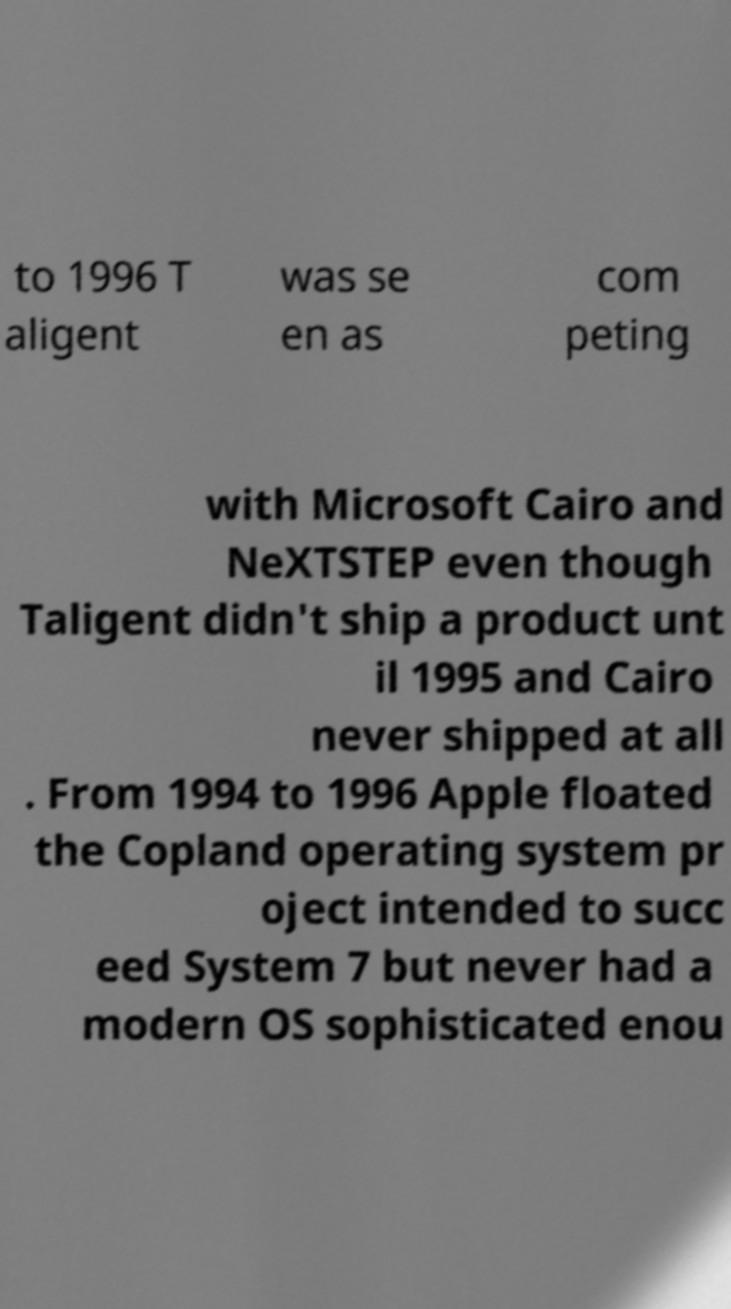There's text embedded in this image that I need extracted. Can you transcribe it verbatim? to 1996 T aligent was se en as com peting with Microsoft Cairo and NeXTSTEP even though Taligent didn't ship a product unt il 1995 and Cairo never shipped at all . From 1994 to 1996 Apple floated the Copland operating system pr oject intended to succ eed System 7 but never had a modern OS sophisticated enou 